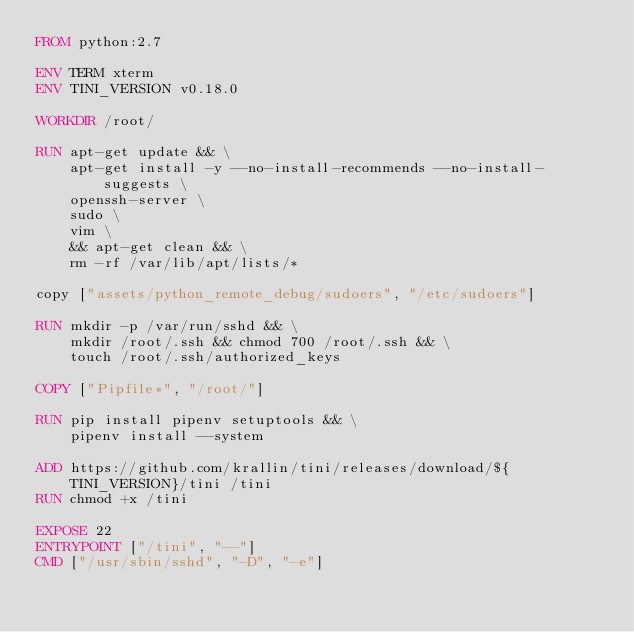Convert code to text. <code><loc_0><loc_0><loc_500><loc_500><_Dockerfile_>FROM python:2.7

ENV TERM xterm
ENV TINI_VERSION v0.18.0

WORKDIR /root/

RUN apt-get update && \
    apt-get install -y --no-install-recommends --no-install-suggests \
    openssh-server \
    sudo \
    vim \
    && apt-get clean && \
    rm -rf /var/lib/apt/lists/*

copy ["assets/python_remote_debug/sudoers", "/etc/sudoers"]

RUN mkdir -p /var/run/sshd && \
    mkdir /root/.ssh && chmod 700 /root/.ssh && \
    touch /root/.ssh/authorized_keys

COPY ["Pipfile*", "/root/"]

RUN pip install pipenv setuptools && \
    pipenv install --system

ADD https://github.com/krallin/tini/releases/download/${TINI_VERSION}/tini /tini
RUN chmod +x /tini

EXPOSE 22
ENTRYPOINT ["/tini", "--"]
CMD ["/usr/sbin/sshd", "-D", "-e"]
</code> 